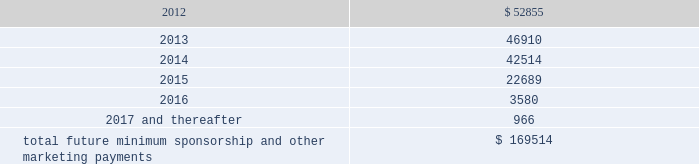Operating lease agreements .
Included in these amounts was contingent rent expense of $ 3.6 million , $ 2.0 million and $ 0.6 million for the years ended december 31 , 2011 , 2010 and 2009 , respectively .
The operating lease obligations included above do not include any contingent rent .
Sponsorships and other marketing commitments within the normal course of business , the company enters into contractual commitments in order to promote the company 2019s brand and products .
These commitments include sponsorship agreements with teams and athletes on the collegiate and professional levels , official supplier agreements , athletic event sponsorships and other marketing commitments .
The following is a schedule of the company 2019s future minimum payments under its sponsorship and other marketing agreements as of december 31 , 2011 : ( in thousands ) .
The amounts listed above are the minimum obligations required to be paid under the company 2019s sponsorship and other marketing agreements .
The amounts listed above do not include additional performance incentives and product supply obligations provided under certain agreements .
It is not possible to determine how much the company will spend on product supply obligations on an annual basis as contracts generally do not stipulate specific cash amounts to be spent on products .
The amount of product provided to the sponsorships depends on many factors including general playing conditions , the number of sporting events in which they participate and the company 2019s decisions regarding product and marketing initiatives .
In addition , the costs to design , develop , source and purchase the products furnished to the endorsers are incurred over a period of time and are not necessarily tracked separately from similar costs incurred for products sold to customers .
The company is , from time to time , involved in routine legal matters incidental to its business .
The company believes that the ultimate resolution of any such current proceedings and claims will not have a material adverse effect on its consolidated financial position , results of operations or cash flows .
In connection with various contracts and agreements , the company has agreed to indemnify counterparties against certain third party claims relating to the infringement of intellectual property rights and other items .
Generally , such indemnification obligations do not apply in situations in which the counterparties are grossly negligent , engage in willful misconduct , or act in bad faith .
Based on the company 2019s historical experience and the estimated probability of future loss , the company has determined that the fair value of such indemnifications is not material to its consolidated financial position or results of operations .
Stockholders 2019 equity the company 2019s class a common stock and class b convertible common stock have an authorized number of shares of 100.0 million shares and 11.3 million shares , respectively , and each have a par value of $ 0.0003 1/3 per share .
Holders of class a common stock and class b convertible common stock have identical rights , including liquidation preferences , except that the holders of class a common stock are entitled to one vote per share and holders of class b convertible common stock are entitled to 10 votes per share on all matters submitted to a stockholder vote .
Class b convertible common stock may only be held by kevin plank .
As of december 31 , 2012 what was the percent of the company 2019s future minimum payments under its sponsorship and other marketing agreements to the total? 
Computations: (52855 / 169514)
Answer: 0.3118. 